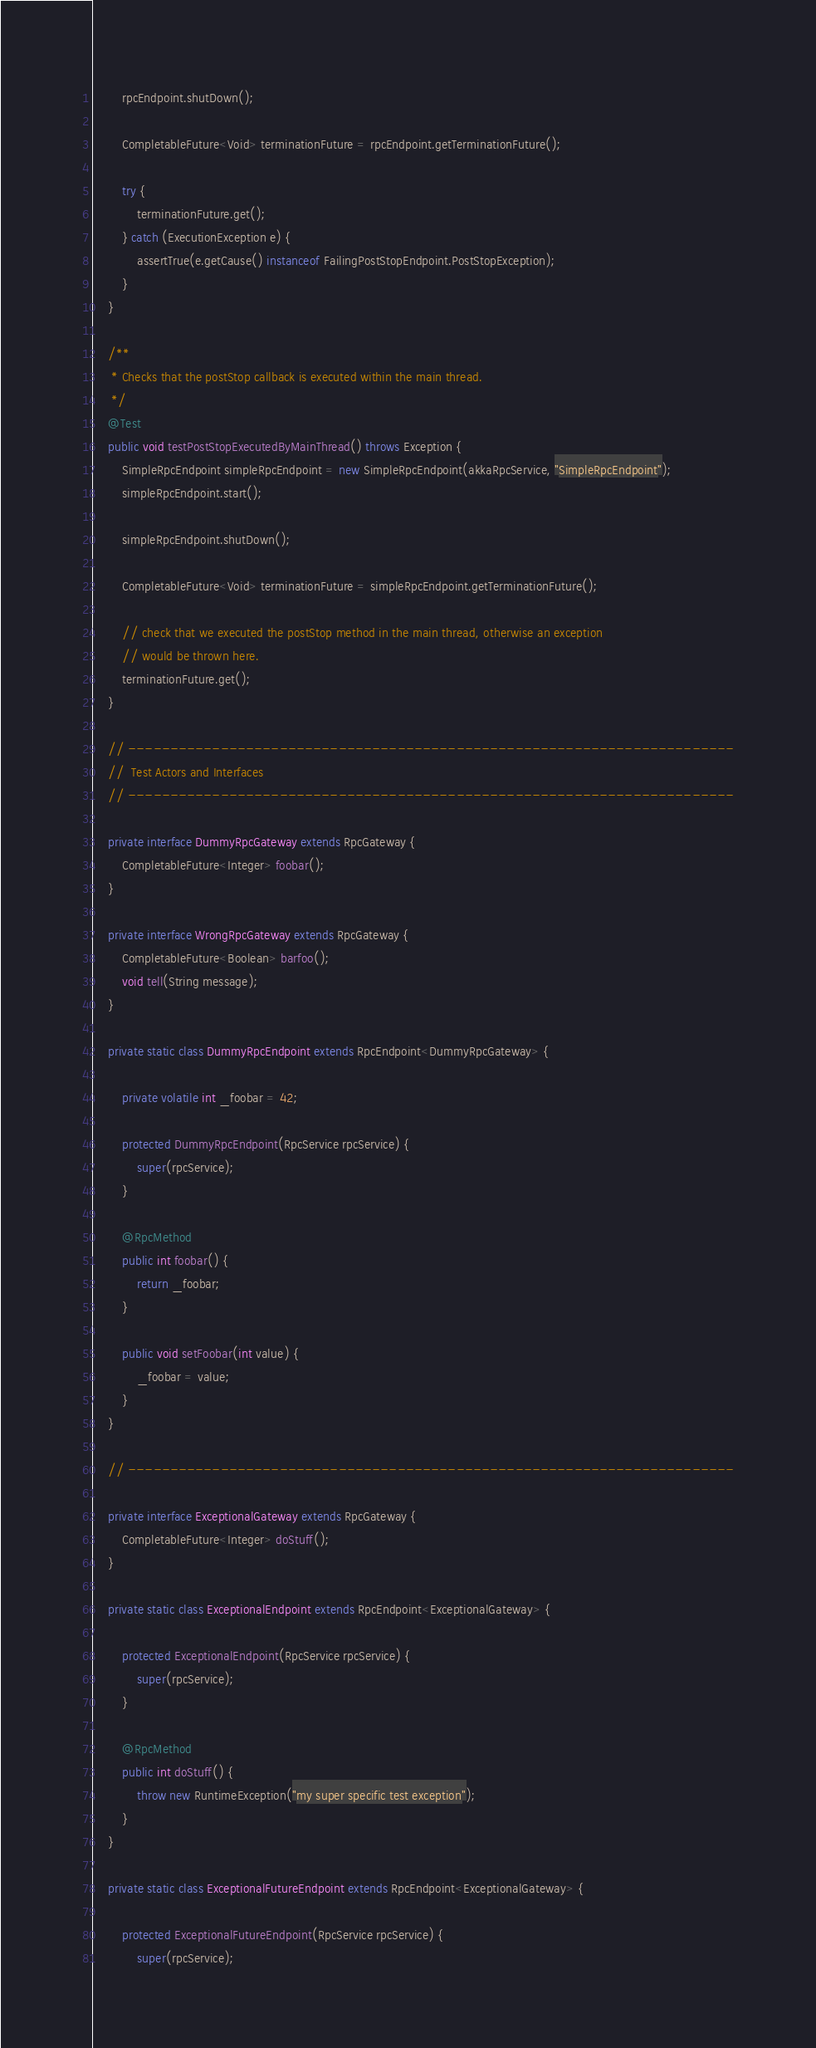Convert code to text. <code><loc_0><loc_0><loc_500><loc_500><_Java_>		rpcEndpoint.shutDown();

		CompletableFuture<Void> terminationFuture = rpcEndpoint.getTerminationFuture();

		try {
			terminationFuture.get();
		} catch (ExecutionException e) {
			assertTrue(e.getCause() instanceof FailingPostStopEndpoint.PostStopException);
		}
	}

	/**
	 * Checks that the postStop callback is executed within the main thread.
	 */
	@Test
	public void testPostStopExecutedByMainThread() throws Exception {
		SimpleRpcEndpoint simpleRpcEndpoint = new SimpleRpcEndpoint(akkaRpcService, "SimpleRpcEndpoint");
		simpleRpcEndpoint.start();

		simpleRpcEndpoint.shutDown();

		CompletableFuture<Void> terminationFuture = simpleRpcEndpoint.getTerminationFuture();

		// check that we executed the postStop method in the main thread, otherwise an exception
		// would be thrown here.
		terminationFuture.get();
	}

	// ------------------------------------------------------------------------
	//  Test Actors and Interfaces
	// ------------------------------------------------------------------------

	private interface DummyRpcGateway extends RpcGateway {
		CompletableFuture<Integer> foobar();
	}

	private interface WrongRpcGateway extends RpcGateway {
		CompletableFuture<Boolean> barfoo();
		void tell(String message);
	}

	private static class DummyRpcEndpoint extends RpcEndpoint<DummyRpcGateway> {

		private volatile int _foobar = 42;

		protected DummyRpcEndpoint(RpcService rpcService) {
			super(rpcService);
		}

		@RpcMethod
		public int foobar() {
			return _foobar;
		}

		public void setFoobar(int value) {
			_foobar = value;
		}
	}

	// ------------------------------------------------------------------------

	private interface ExceptionalGateway extends RpcGateway {
		CompletableFuture<Integer> doStuff();
	}

	private static class ExceptionalEndpoint extends RpcEndpoint<ExceptionalGateway> {

		protected ExceptionalEndpoint(RpcService rpcService) {
			super(rpcService);
		}

		@RpcMethod
		public int doStuff() {
			throw new RuntimeException("my super specific test exception");
		}
	}

	private static class ExceptionalFutureEndpoint extends RpcEndpoint<ExceptionalGateway> {

		protected ExceptionalFutureEndpoint(RpcService rpcService) {
			super(rpcService);</code> 